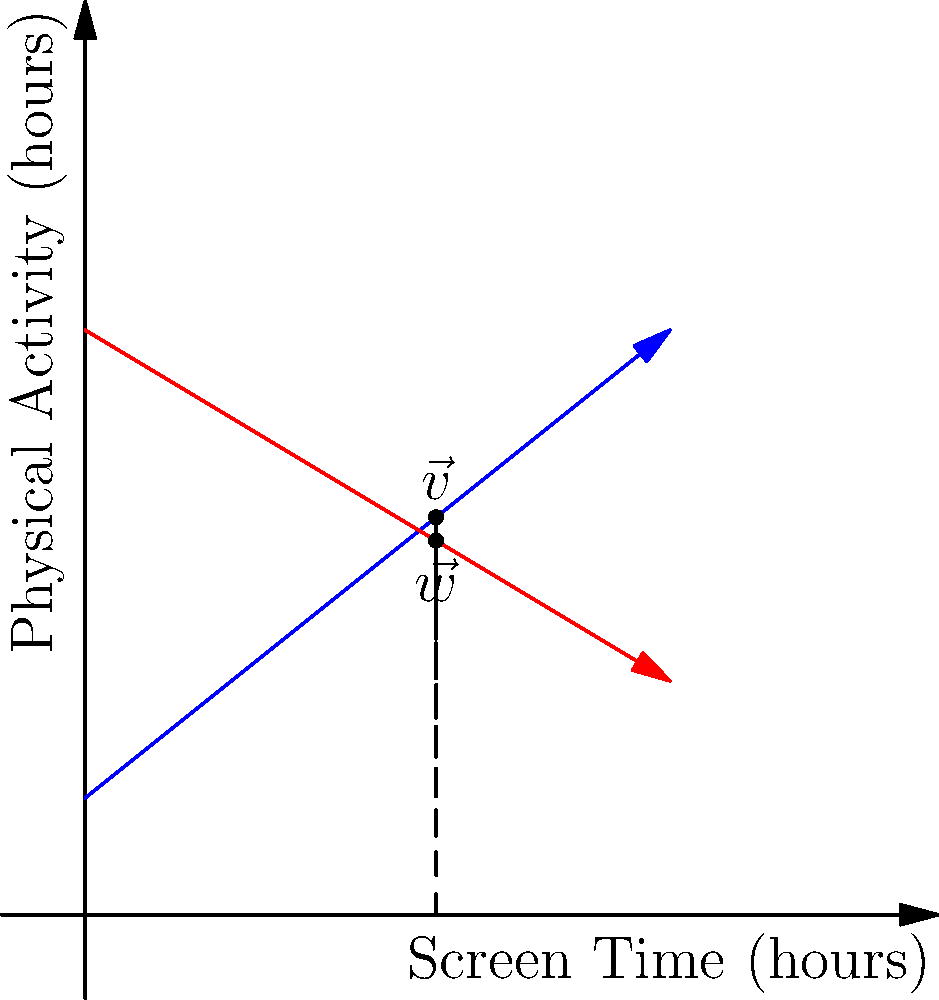In the graph above, vector $\vec{v}$ (blue) represents the relationship between screen time and physical activity for children who participate in an obesity prevention program, while vector $\vec{w}$ (red) represents the same relationship for children who do not participate. Calculate the scalar projection of $\vec{w}$ onto $\vec{v}$. What does this value indicate about the effectiveness of the obesity prevention program? To solve this problem, we'll follow these steps:

1) First, we need to determine the components of vectors $\vec{v}$ and $\vec{w}$. From the graph:
   $\vec{v} = (5, 5)$ (approximate endpoint of blue vector)
   $\vec{w} = (5, 2)$ (approximate endpoint of red vector)

2) The formula for scalar projection of $\vec{w}$ onto $\vec{v}$ is:
   $proj_{\vec{v}}\vec{w} = \frac{\vec{w} \cdot \vec{v}}{|\vec{v}|}$

3) Calculate the dot product $\vec{w} \cdot \vec{v}$:
   $\vec{w} \cdot \vec{v} = (5)(5) + (2)(5) = 25 + 10 = 35$

4) Calculate the magnitude of $\vec{v}$:
   $|\vec{v}| = \sqrt{5^2 + 5^2} = \sqrt{50} = 5\sqrt{2}$

5) Now, we can calculate the scalar projection:
   $proj_{\vec{v}}\vec{w} = \frac{35}{5\sqrt{2}} = \frac{7\sqrt{2}}{2} \approx 4.95$

6) Interpret the result:
   The scalar projection is positive and close to the magnitude of $\vec{v}$ (which is $5\sqrt{2} \approx 7.07$). This indicates that $\vec{w}$ has a strong component in the direction of $\vec{v}$.

In the context of the obesity prevention program, this suggests that even children who don't participate in the program (represented by $\vec{w}$) show a similar trend in the relationship between screen time and physical activity as those who do participate (represented by $\vec{v}$). However, the magnitude of $\vec{w}$ is smaller, indicating that the program may still have some positive effect on increasing physical activity or reducing screen time.
Answer: $\frac{7\sqrt{2}}{2}$; indicates similar trend but smaller magnitude for non-participants 